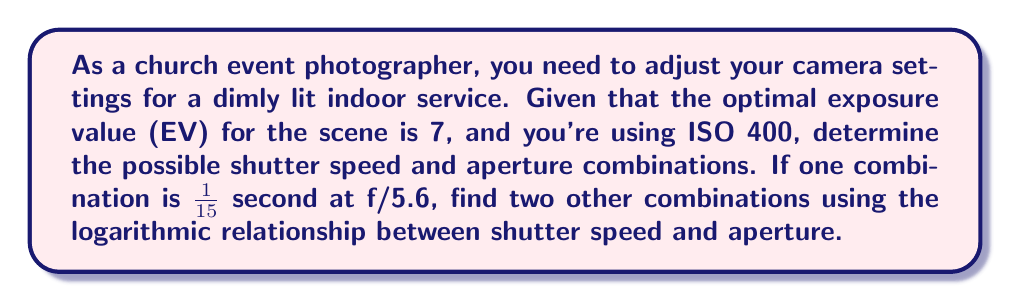Provide a solution to this math problem. To solve this problem, we'll use the exposure value (EV) formula and the relationship between shutter speed and aperture.

1) The EV formula is:
   $$EV = \log_2\left(\frac{N^2}{t}\right) + \log_2\left(\frac{ISO}{100}\right)$$
   where $N$ is the f-number (aperture) and $t$ is the shutter speed in seconds.

2) Given: EV = 7, ISO = 400, and one combination is 1/15 s at f/5.6

3) Let's verify this combination using the EV formula:
   $$7 = \log_2\left(\frac{5.6^2}{1/15}\right) + \log_2\left(\frac{400}{100}\right)$$
   $$7 = \log_2(470.4) + 2 = 8.88 + 2 = 10.88 - 4 = 6.88 \approx 7$$

4) To find other combinations, we can use the fact that doubling the shutter speed allows us to increase the f-number by one stop (multiply by $\sqrt{2}$), maintaining the same EV.

5) For a faster shutter speed:
   New shutter speed: 1/30 s
   New aperture: $5.6 \times \sqrt{2} = 5.6 \times 1.414 \approx 7.9$ (rounded to f/8)

6) For a slower shutter speed:
   New shutter speed: 1/8 s
   New aperture: $5.6 \div \sqrt{2} = 5.6 \div 1.414 \approx 4$ (rounded to f/4)

7) We can verify these new combinations using the EV formula (calculations omitted for brevity).
Answer: Two other shutter speed and aperture combinations that provide the same exposure are:
1) 1/30 second at f/8
2) 1/8 second at f/4 